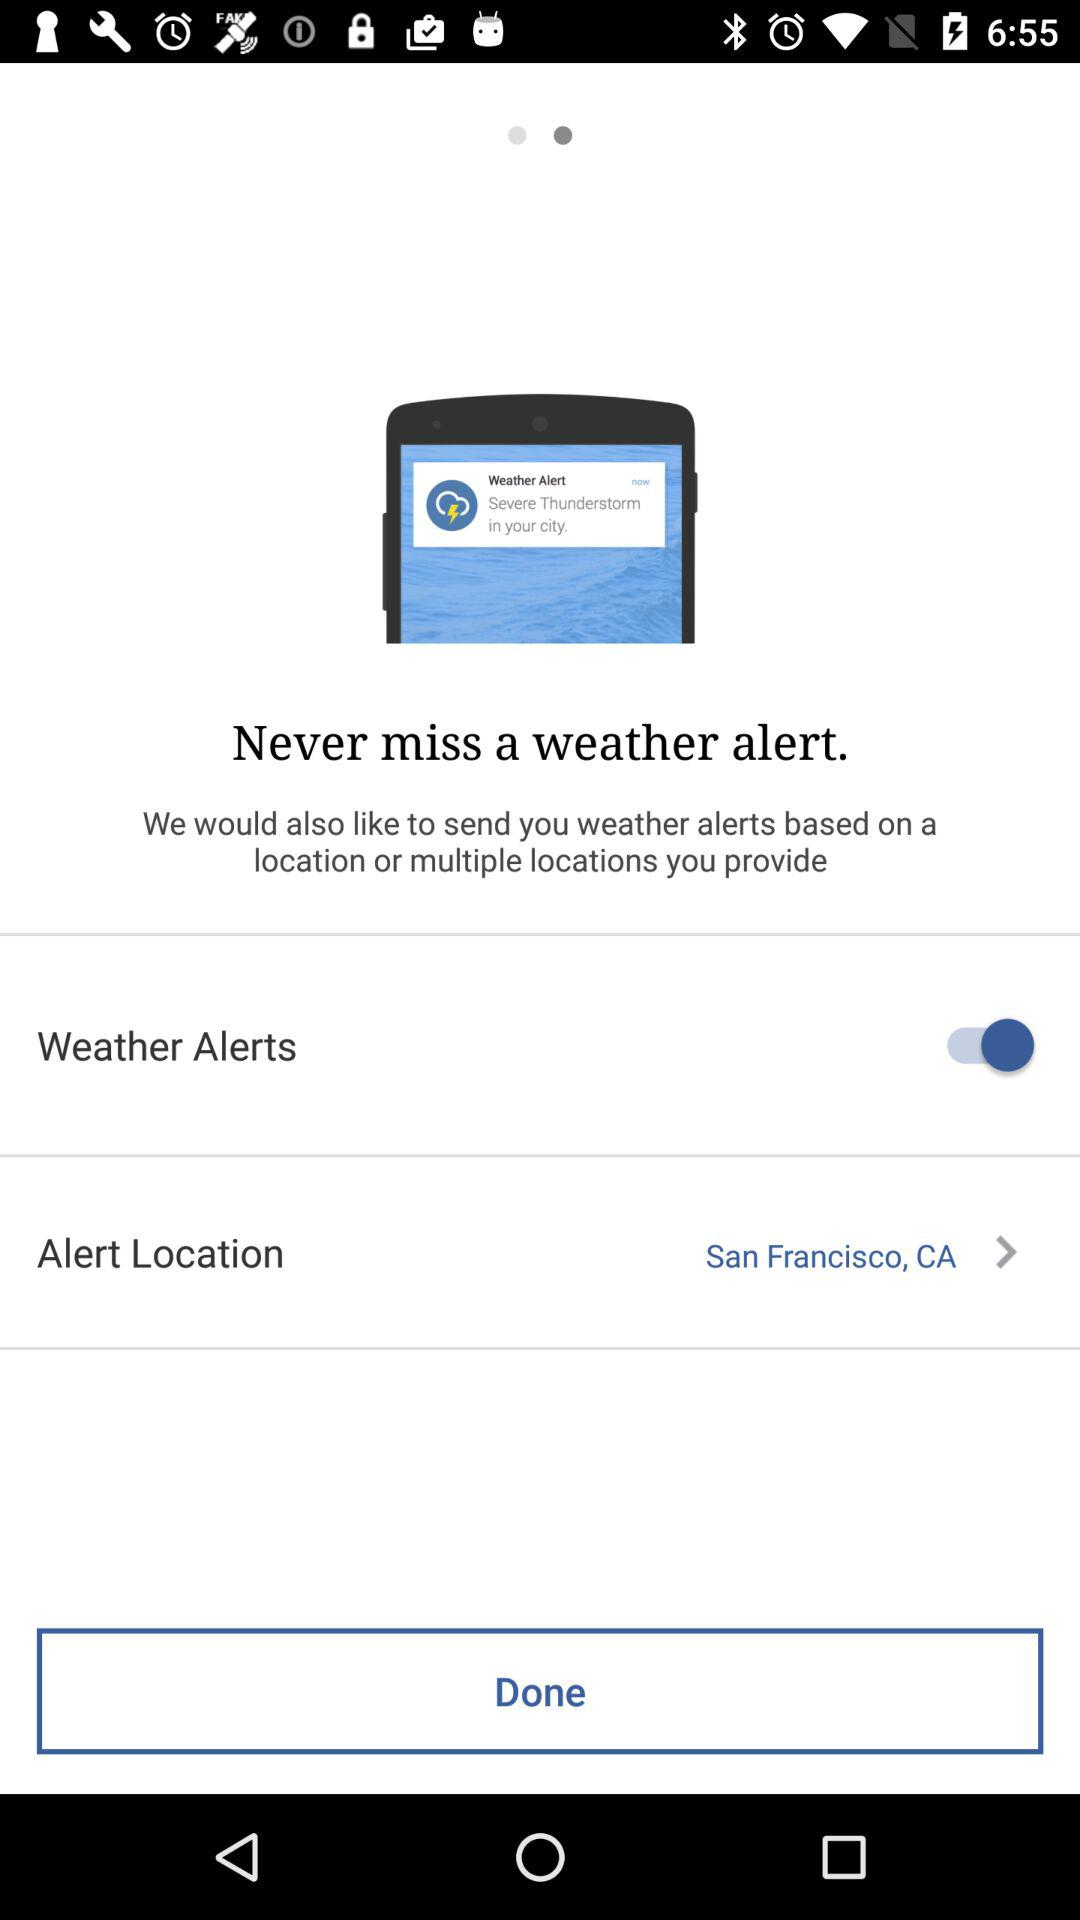What's the status of the "Weather Alerts"? The status of the "Weather Alerts" is "on". 